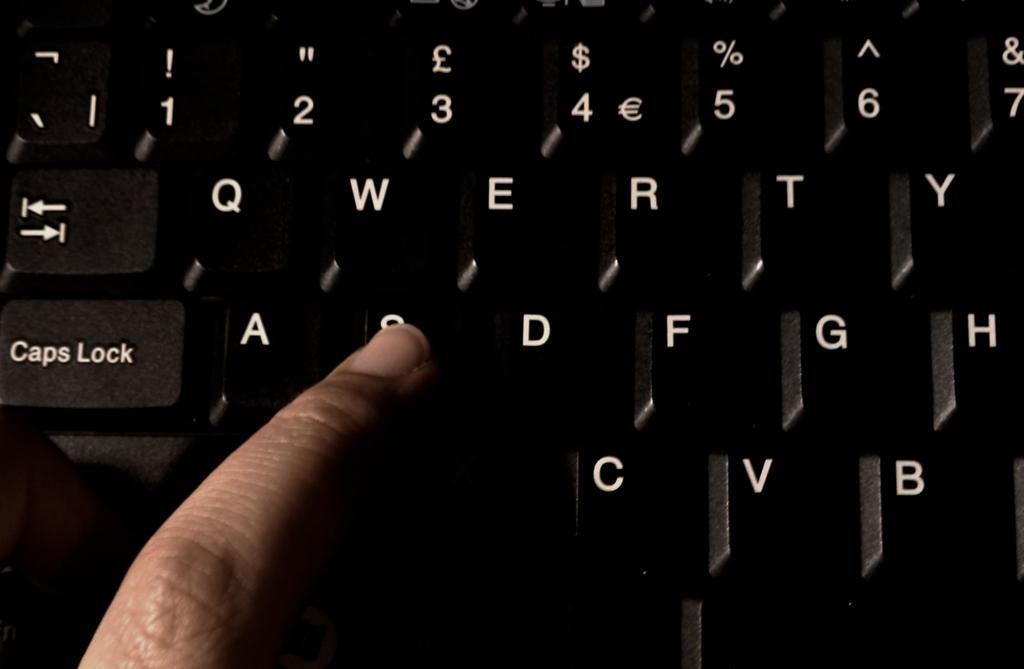Provide a one-sentence caption for the provided image. a person's finger pressing down on keyboard key 's'. 